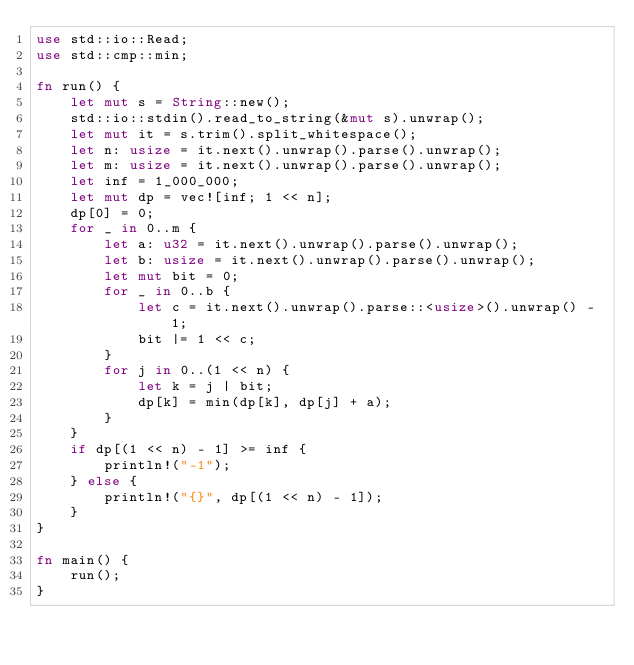Convert code to text. <code><loc_0><loc_0><loc_500><loc_500><_Rust_>use std::io::Read;
use std::cmp::min;

fn run() {
    let mut s = String::new();
    std::io::stdin().read_to_string(&mut s).unwrap();
    let mut it = s.trim().split_whitespace();
    let n: usize = it.next().unwrap().parse().unwrap();
    let m: usize = it.next().unwrap().parse().unwrap();
    let inf = 1_000_000;
    let mut dp = vec![inf; 1 << n];
    dp[0] = 0;
    for _ in 0..m {
        let a: u32 = it.next().unwrap().parse().unwrap();
        let b: usize = it.next().unwrap().parse().unwrap();
        let mut bit = 0;
        for _ in 0..b {
            let c = it.next().unwrap().parse::<usize>().unwrap() - 1;
            bit |= 1 << c;
        }
        for j in 0..(1 << n) {
            let k = j | bit;
            dp[k] = min(dp[k], dp[j] + a);
        }
    }
    if dp[(1 << n) - 1] >= inf {
        println!("-1");
    } else {
        println!("{}", dp[(1 << n) - 1]);
    }
}

fn main() {
    run();
}
</code> 